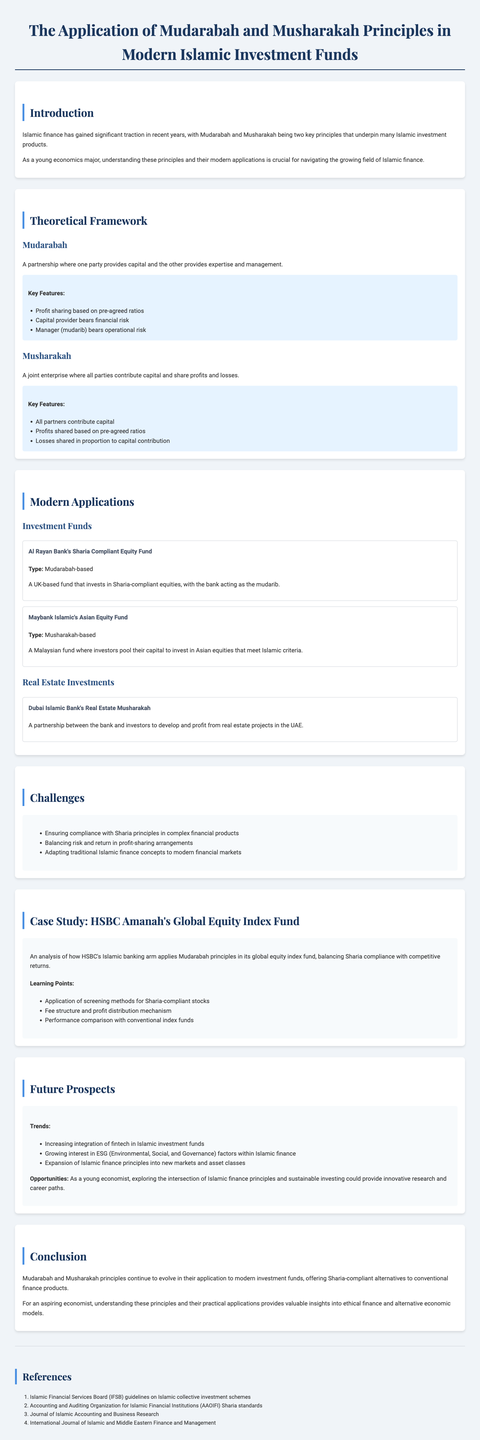What are the two key principles that underpin Islamic investment products? The document states that Mudarabah and Musharakah are the two key principles underpinning Islamic investment products.
Answer: Mudarabah and Musharakah What type of fund is Al Rayan Bank's Sharia Compliant Equity Fund? The document indicates that this fund is Mudarabah-based.
Answer: Mudarabah-based What is the main challenge identified in the report regarding Islamic finance? The report discusses several challenges, and one of them is ensuring compliance with Sharia principles in complex financial products.
Answer: Ensuring compliance with Sharia principles Which bank is involved in Dubai Islamic Bank's Real Estate Musharakah? The document explicitly mentions that Dubai Islamic Bank is the bank involved in this real estate partnership.
Answer: Dubai Islamic Bank What is one of the trends identified in the future prospects of Islamic finance? The report notes the increasing integration of fintech in Islamic investment funds as a trend.
Answer: Increasing integration of fintech What is the title of the case study presented in the report? The document specifies that the title of the case study is HSBC Amanah's Global Equity Index Fund.
Answer: HSBC Amanah's Global Equity Index Fund What percentage of losses are shared in a Musharakah arrangement? The document states that in Musharakah, losses are shared in proportion to capital contribution.
Answer: Proportion to capital contribution What is the opportunity mentioned for young economists in Islamic finance? The report highlights that exploring the intersection of Islamic finance principles and sustainable investing could provide innovative research and career paths.
Answer: Exploring the intersection of Islamic finance principles and sustainable investing 